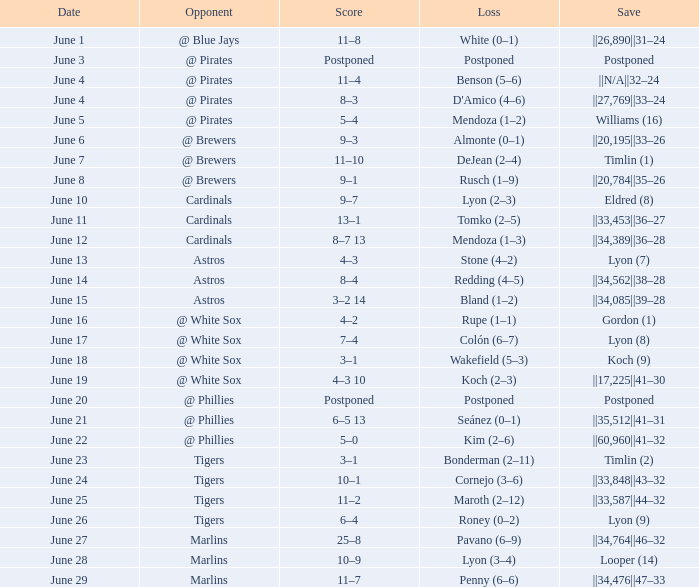Who is the opponent with a save of ||33,453||36–27? Cardinals. 